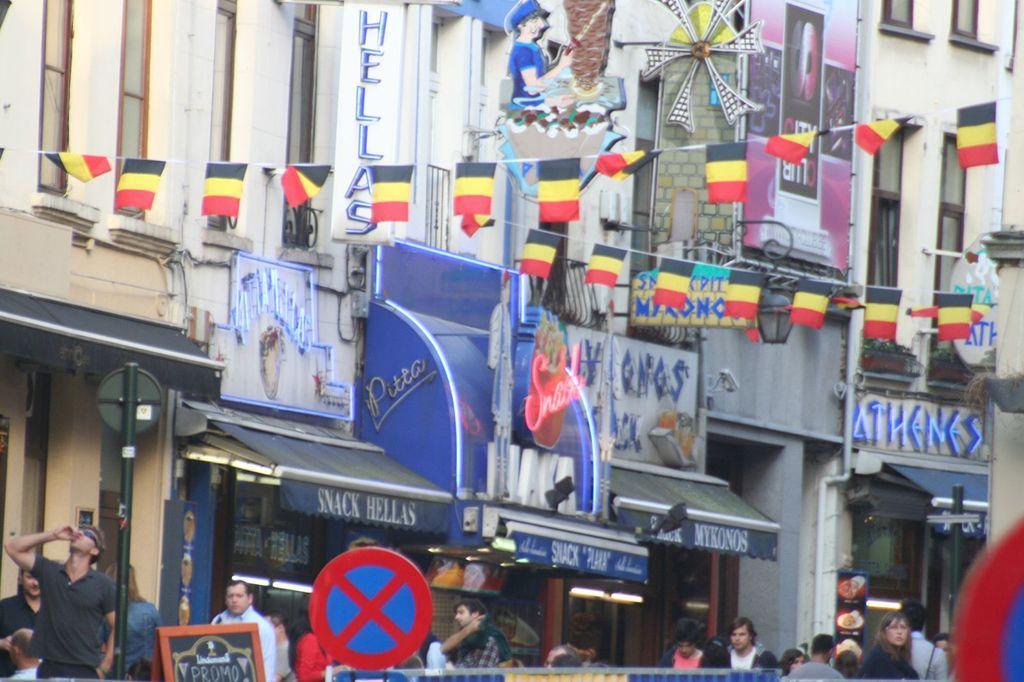Please provide a concise description of this image. In the foreground of this image, there are sign boards. In the background, there are persons, a pole, buildings, tents, bunting flags on the top and a banner. 